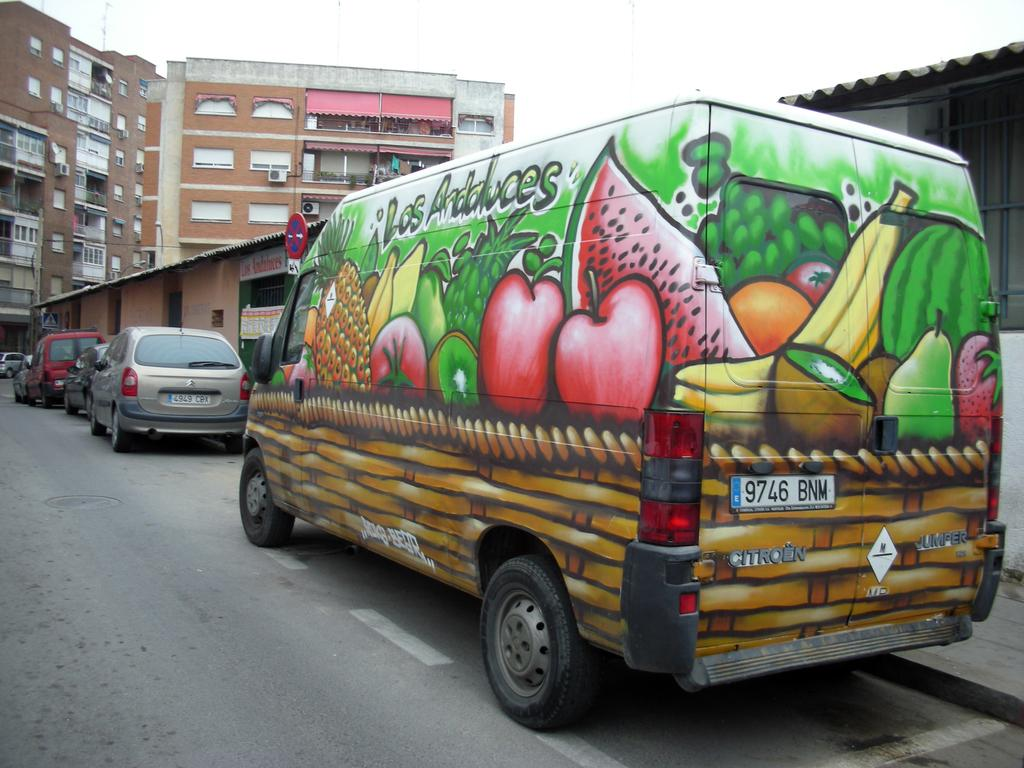What type of structures are visible in the image? There are buildings and houses in the image. What vehicles can be seen parked on the road in the image? Cars and a van are parked on the road in the image. What is the condition of the sky in the image? The sky is cloudy in the image. How many snails can be seen crawling on the buildings in the image? There are no snails visible in the image; it only features buildings, houses, cars, a van, and a cloudy sky. 